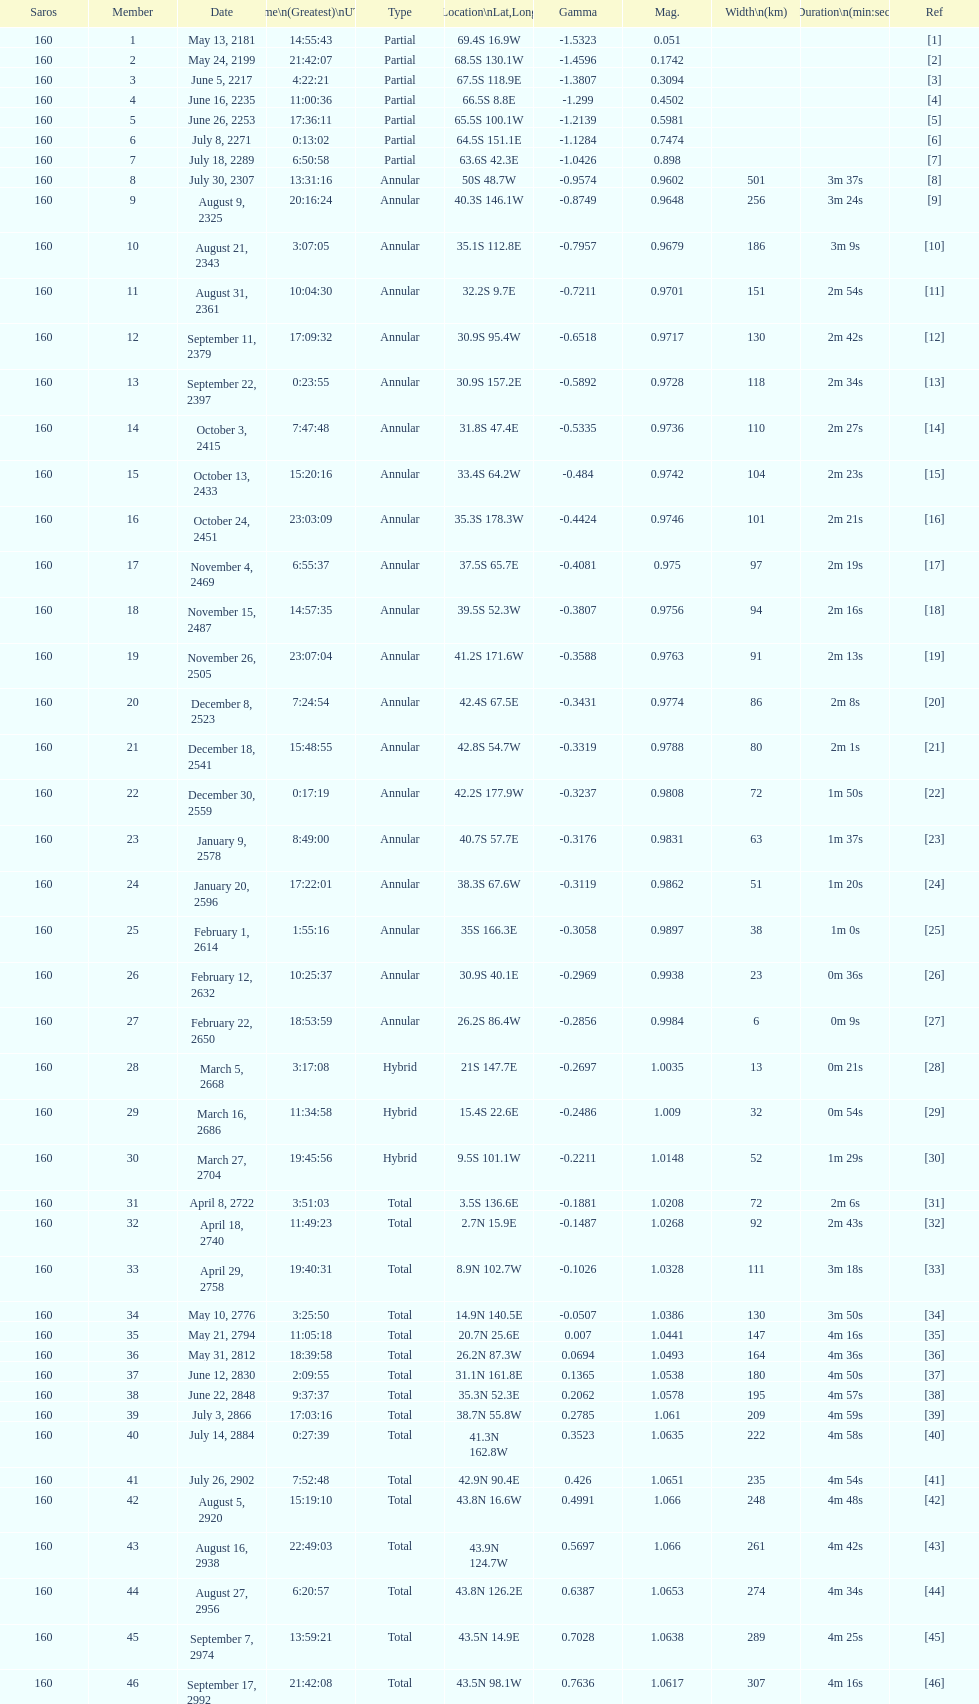When was the occurrence of the first solar saros with a magnitude over March 5, 2668. 